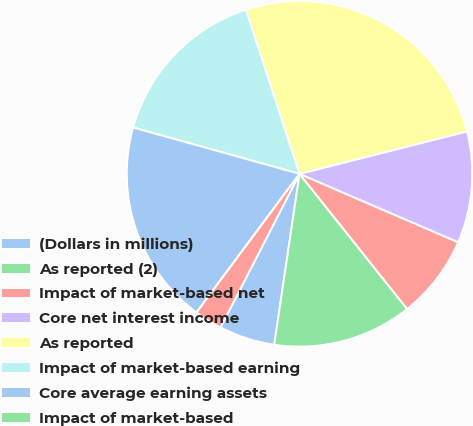Convert chart to OTSL. <chart><loc_0><loc_0><loc_500><loc_500><pie_chart><fcel>(Dollars in millions)<fcel>As reported (2)<fcel>Impact of market-based net<fcel>Core net interest income<fcel>As reported<fcel>Impact of market-based earning<fcel>Core average earning assets<fcel>Impact of market-based<fcel>Core net interest yield on<nl><fcel>5.22%<fcel>13.04%<fcel>7.82%<fcel>10.43%<fcel>26.08%<fcel>15.65%<fcel>19.15%<fcel>0.0%<fcel>2.61%<nl></chart> 